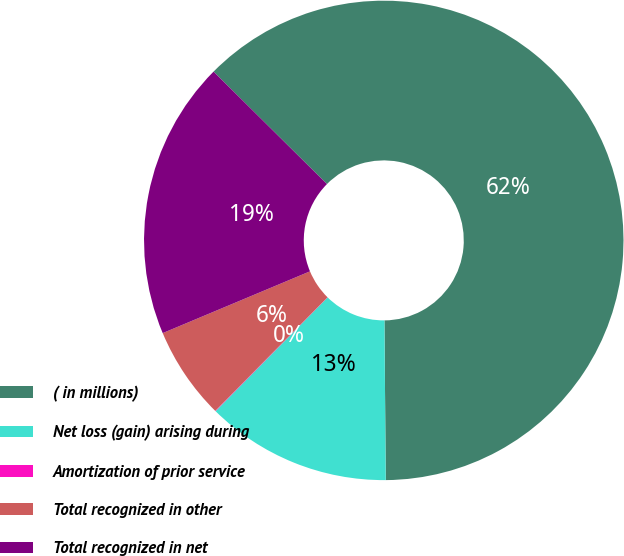Convert chart to OTSL. <chart><loc_0><loc_0><loc_500><loc_500><pie_chart><fcel>( in millions)<fcel>Net loss (gain) arising during<fcel>Amortization of prior service<fcel>Total recognized in other<fcel>Total recognized in net<nl><fcel>62.43%<fcel>12.51%<fcel>0.03%<fcel>6.27%<fcel>18.75%<nl></chart> 